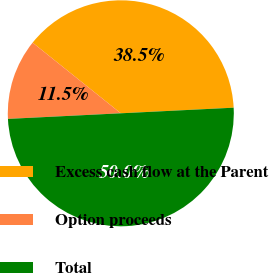Convert chart to OTSL. <chart><loc_0><loc_0><loc_500><loc_500><pie_chart><fcel>Excess cash flow at the Parent<fcel>Option proceeds<fcel>Total<nl><fcel>38.46%<fcel>11.54%<fcel>50.0%<nl></chart> 